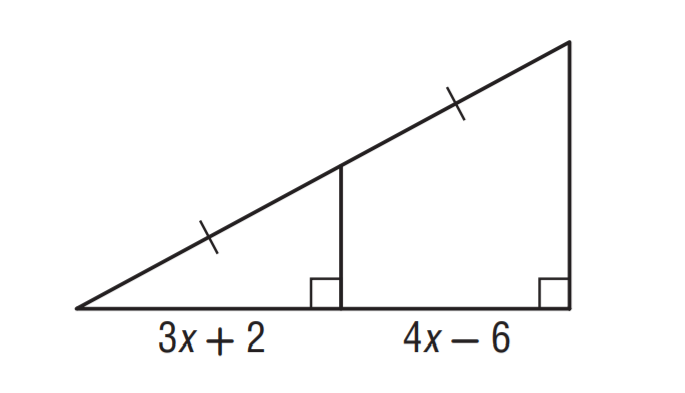Answer the mathemtical geometry problem and directly provide the correct option letter.
Question: Find x.
Choices: A: 4 B: 6 C: 8 D: 10 C 